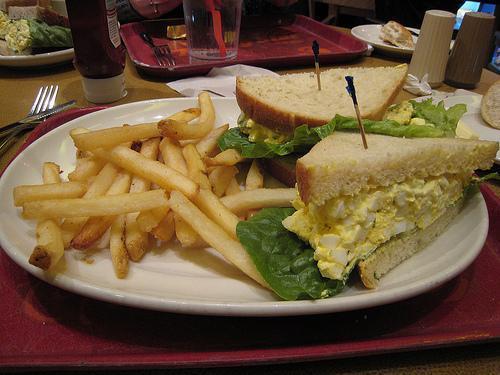How many forks can be seen?
Give a very brief answer. 2. 